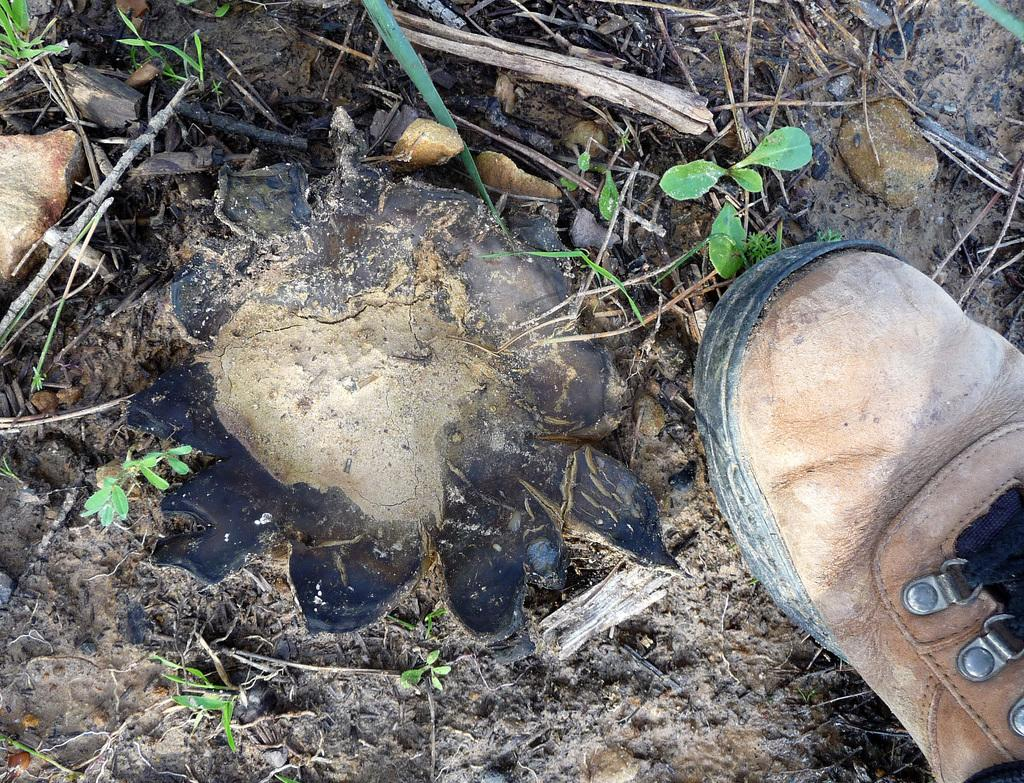What object is present on the ground in the image? There is a shoe in the image. Can you describe the position of the shoe in the image? The shoe is placed on the ground. What type of sign is the minister holding in the image? There is no sign or minister present in the image; it only features a shoe placed on the ground. 